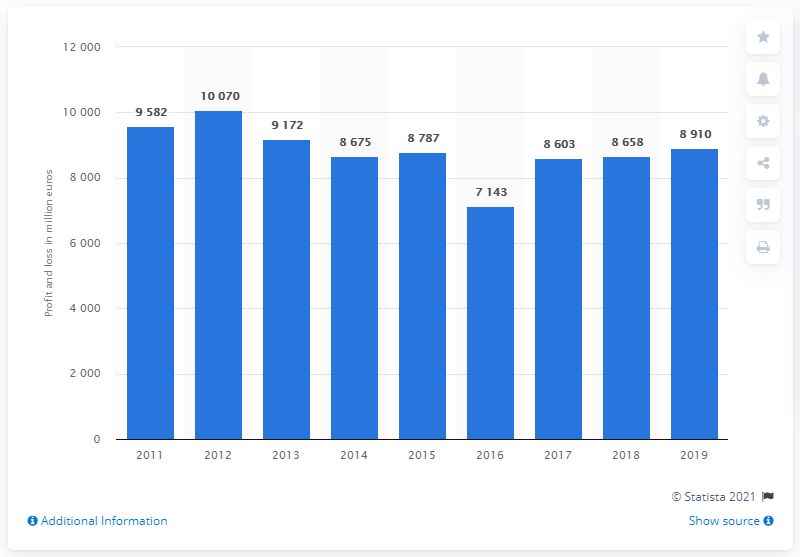Outline some significant characteristics in this image. The sum of 2016 to 2019 is 33314... The highest value is 10070 and... UniCredit's operating profit in 2019 was 8,910. 